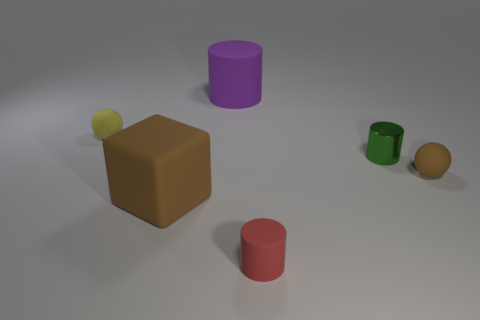Are there any other things that are the same material as the green cylinder?
Your answer should be very brief. No. There is another small object that is the same shape as the small metallic thing; what is its color?
Give a very brief answer. Red. Is the material of the large object that is in front of the tiny green object the same as the small cylinder behind the tiny brown rubber sphere?
Give a very brief answer. No. There is a block; is its color the same as the tiny sphere to the right of the big matte cylinder?
Your answer should be very brief. Yes. What shape is the rubber thing that is both left of the purple cylinder and on the right side of the tiny yellow thing?
Your answer should be very brief. Cube. How many small yellow cylinders are there?
Your answer should be very brief. 0. What is the shape of the tiny thing that is the same color as the block?
Your response must be concise. Sphere. What size is the purple matte thing that is the same shape as the small green thing?
Make the answer very short. Large. Do the tiny matte object right of the tiny red object and the yellow rubber thing have the same shape?
Give a very brief answer. Yes. What is the color of the small object to the right of the small green metal thing?
Offer a very short reply. Brown. 